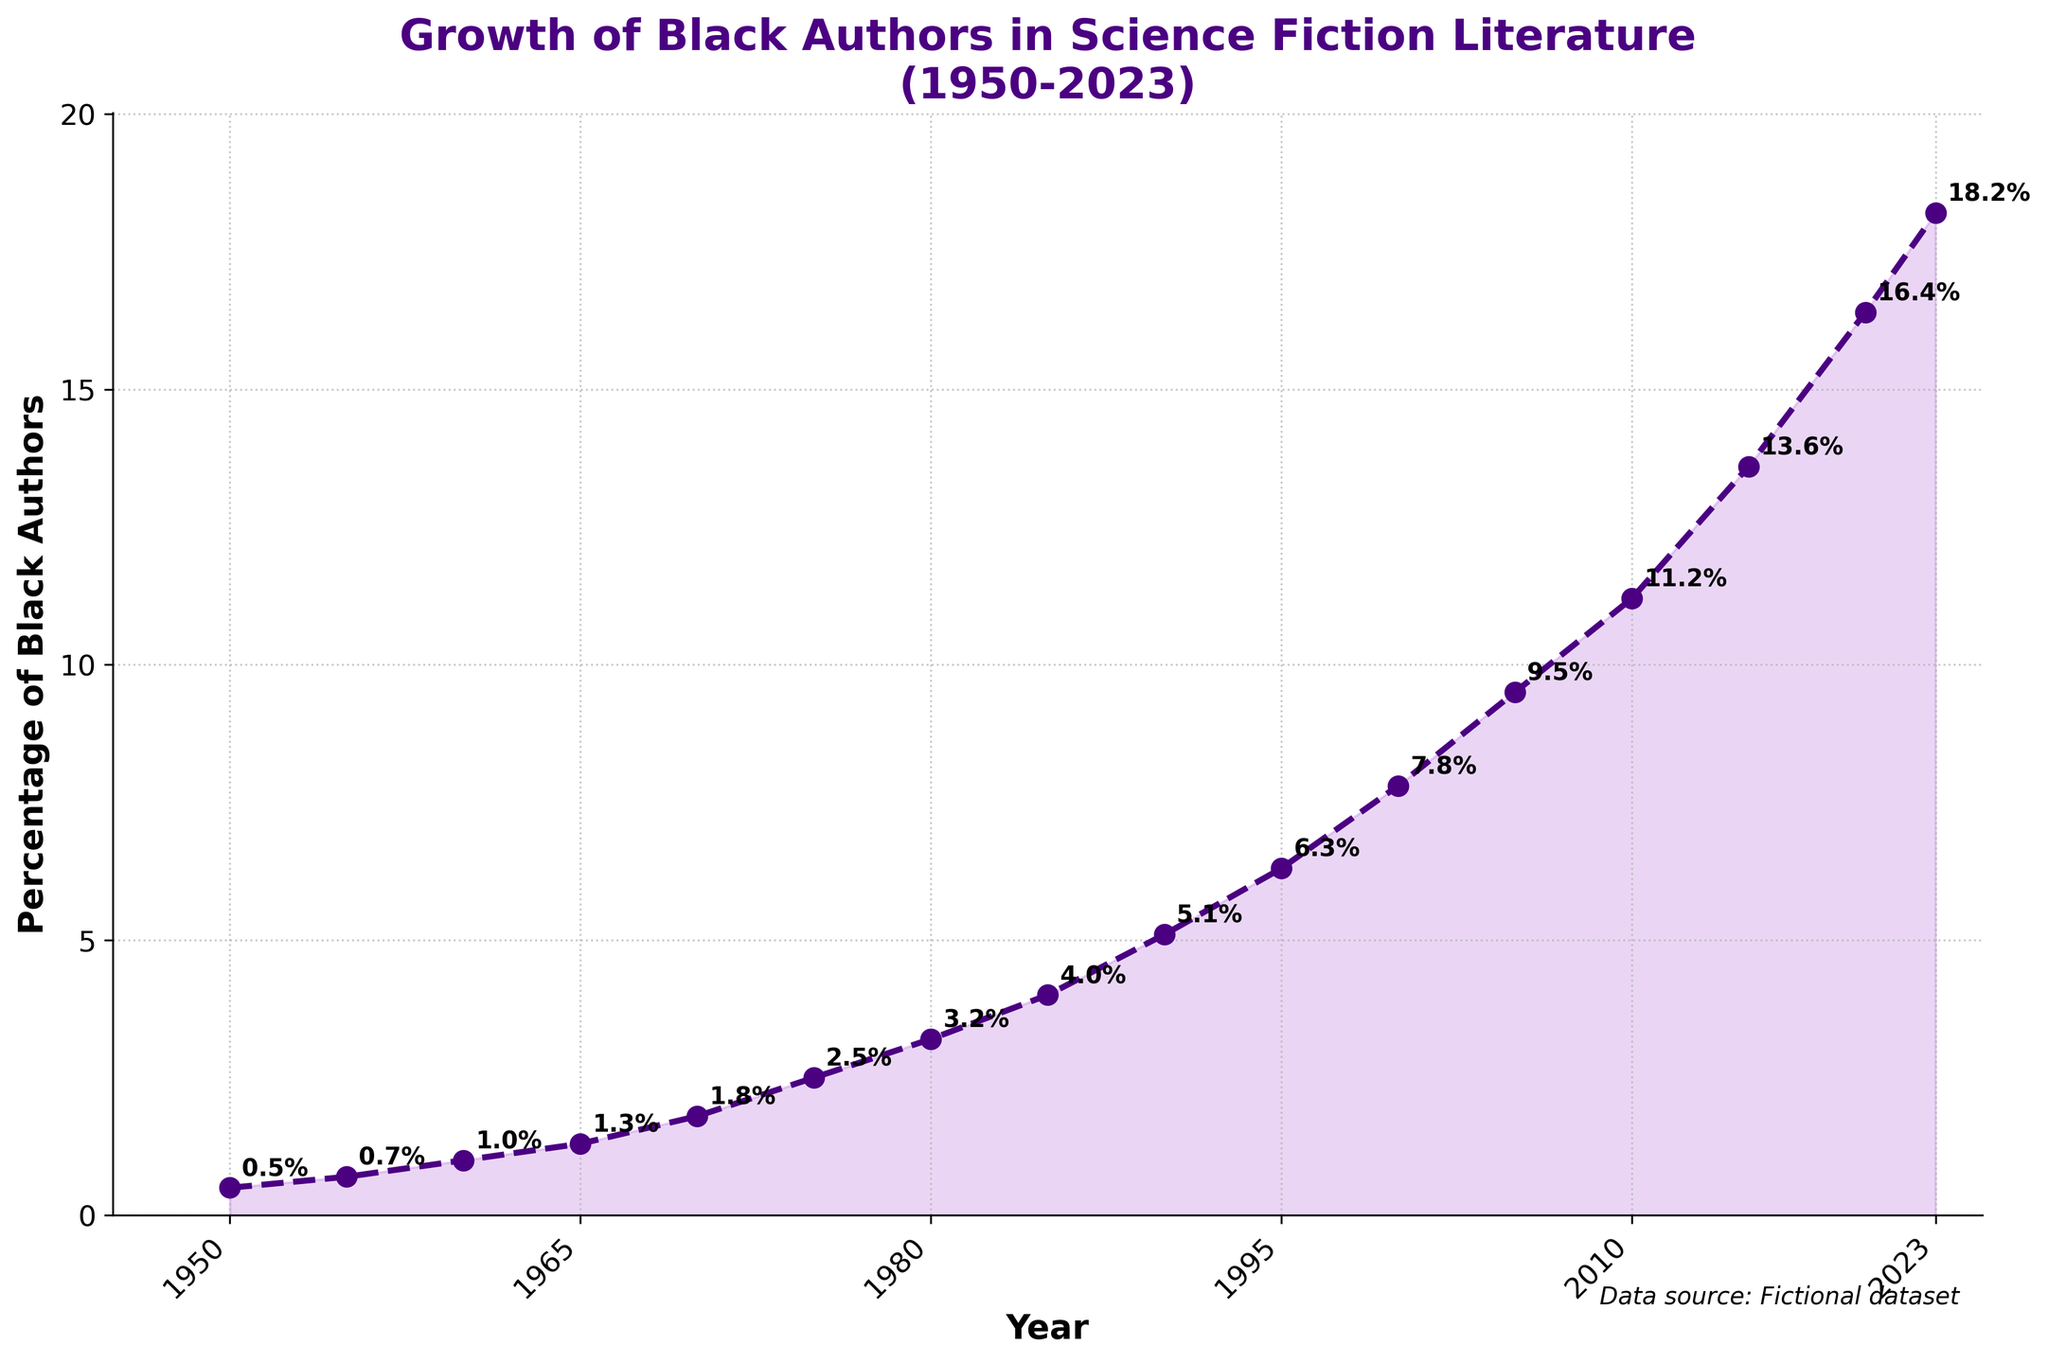What's the highest percentage of Black authors shown in the figure? The highest percentage can be found at the end of the line plot, which is 18.2% in the year 2023.
Answer: 18.2% How many percentage points did the representation of Black authors increase between 1950 and 2000? Subtract the percentage in 1950 (0.5%) from the percentage in 2000 (7.8%). 7.8% - 0.5% = 7.3%.
Answer: 7.3% During which decade did the percentage of Black authors first exceed 10%? Observe the line plot and find the first year where the percentage crosses 10%, which happens between 2005 (9.5%) and 2010 (11.2%). Thus, the decade is the 2010s.
Answer: 2010s What is the average percentage of Black authors from 1950 to 2023? Sum the percentages (0.5+0.7+1.0+1.3+1.8+2.5+3.2+4.0+5.1+6.3+7.8+9.5+11.2+13.6+16.4+18.2) which equals 102.1, then divide by the number of years (16). 102.1 divided by 16 = 6.38125.
Answer: 6.38 Which year saw the smallest increase in the percentage of Black authors compared to the previous year? Compare the differences year by year and find the smallest difference: 
1950-1955: 0.2, 
1955-1960: 0.3, 
1960-1965: 0.3, 
1965-1970: 0.5, 
1970-1975: 0.7, 
1975-1980: 0.7, 
1980-1985: 0.8, 
1985-1990: 1.1, 
1990-1995: 1.2, 
1995-2000: 1.5, 
2000-2005: 1.7, 
2005-2010: 1.7, 
2010-2015: 2.4, 
2015-2020: 2.8, 
2020-2023: 1.8. The smallest difference is 0.2, from 1950 to 1955.
Answer: 1955 How many decades saw an increase in the percentage of Black authors by more than 2 percentage points? Calculate the increase per decade and count: 
1950-1960: (0.5 to 1.0) 0.5, 
1960-1970: (1.0 to 1.8) 0.8, 
1970-1980: (1.8 to 3.2) 1.4, 
1980-1990: (3.2 to 5.1) 1.9, 
1990-2000: (5.1 to 7.8) 2.7, 
2000-2010: (7.8 to 11.2) 3.4, 
2010-2020: (11.2 to 16.4) 5.2. Three decades saw an increase of more than 2 percentage points.
Answer: 3 What's the percentage difference between 1975 and 1985? Subtract the percentage in 1975 (2.5%) from the percentage in 1985 (4.0%). 4.0% - 2.5% = 1.5%.
Answer: 1.5% What is the overall trend in the percentage of Black authors in science fiction literature from 1950 to 2023? The line chart consistently increases from 0.5% in 1950 to 18.2% in 2023, indicating a steady upward trend.
Answer: Steady upward trend 